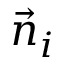<formula> <loc_0><loc_0><loc_500><loc_500>\ V e c { n } _ { i }</formula> 